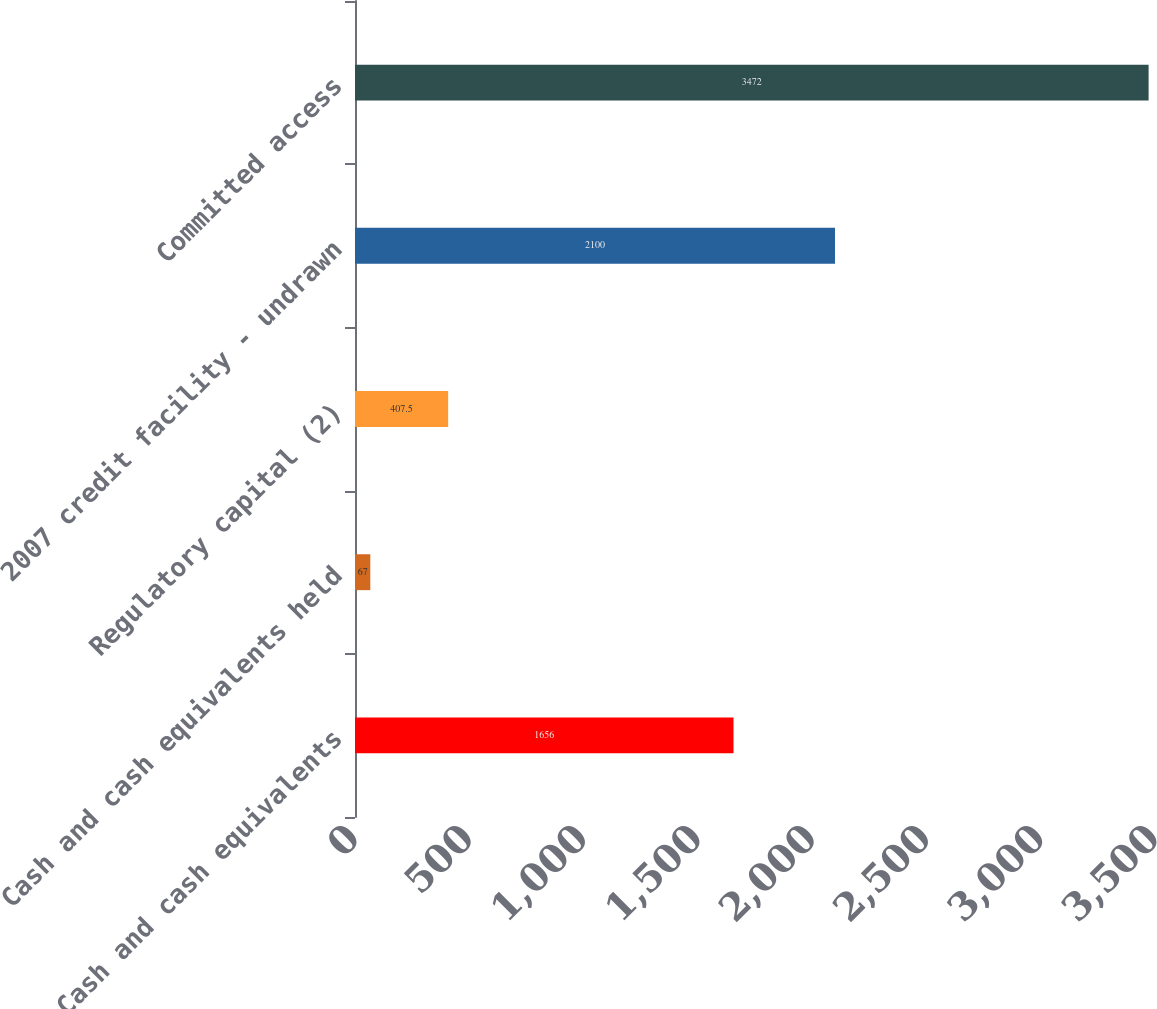Convert chart to OTSL. <chart><loc_0><loc_0><loc_500><loc_500><bar_chart><fcel>Cash and cash equivalents<fcel>Cash and cash equivalents held<fcel>Regulatory capital (2)<fcel>2007 credit facility - undrawn<fcel>Committed access<nl><fcel>1656<fcel>67<fcel>407.5<fcel>2100<fcel>3472<nl></chart> 